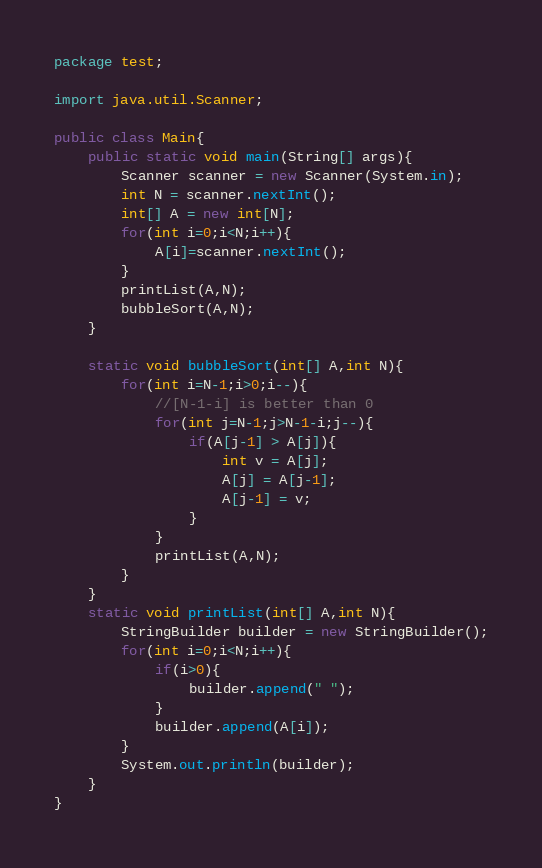<code> <loc_0><loc_0><loc_500><loc_500><_Java_>package test;

import java.util.Scanner;

public class Main{
    public static void main(String[] args){
        Scanner scanner = new Scanner(System.in);
        int N = scanner.nextInt();
        int[] A = new int[N];
        for(int i=0;i<N;i++){
            A[i]=scanner.nextInt();
        }
        printList(A,N);
        bubbleSort(A,N);
    }
     
    static void bubbleSort(int[] A,int N){
        for(int i=N-1;i>0;i--){
        	//[N-1-i] is better than 0
        	for(int j=N-1;j>N-1-i;j--){
        		if(A[j-1] > A[j]){
        			int v = A[j];
        			A[j] = A[j-1];
        			A[j-1] = v;
        		}
        	}
        	printList(A,N);
        }
    }
    static void printList(int[] A,int N){
        StringBuilder builder = new StringBuilder();
        for(int i=0;i<N;i++){
            if(i>0){
                builder.append(" ");
            }
            builder.append(A[i]);
        }
        System.out.println(builder);
    }
}</code> 